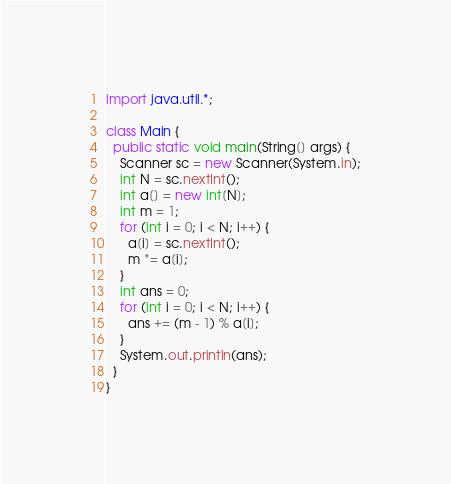<code> <loc_0><loc_0><loc_500><loc_500><_Java_>import java.util.*;

class Main {
  public static void main(String[] args) {
    Scanner sc = new Scanner(System.in);
    int N = sc.nextInt();
    int a[] = new int[N];
    int m = 1;
    for (int i = 0; i < N; i++) {
      a[i] = sc.nextInt();
      m *= a[i];
    }
    int ans = 0;
    for (int i = 0; i < N; i++) {
      ans += (m - 1) % a[i];
    }
    System.out.println(ans);
  }
}</code> 